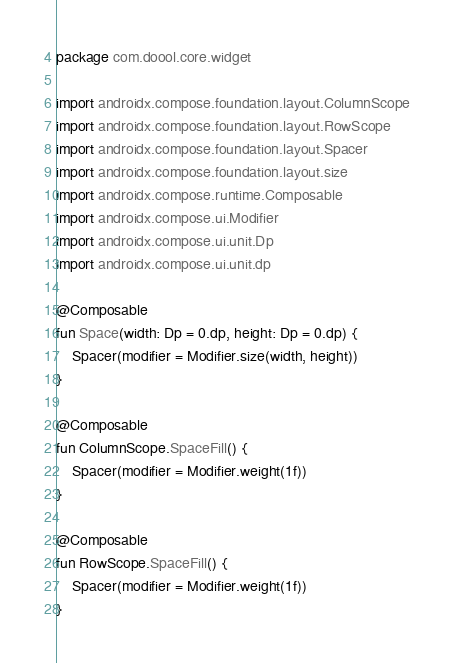Convert code to text. <code><loc_0><loc_0><loc_500><loc_500><_Kotlin_>package com.doool.core.widget

import androidx.compose.foundation.layout.ColumnScope
import androidx.compose.foundation.layout.RowScope
import androidx.compose.foundation.layout.Spacer
import androidx.compose.foundation.layout.size
import androidx.compose.runtime.Composable
import androidx.compose.ui.Modifier
import androidx.compose.ui.unit.Dp
import androidx.compose.ui.unit.dp

@Composable
fun Space(width: Dp = 0.dp, height: Dp = 0.dp) {
    Spacer(modifier = Modifier.size(width, height))
}

@Composable
fun ColumnScope.SpaceFill() {
    Spacer(modifier = Modifier.weight(1f))
}

@Composable
fun RowScope.SpaceFill() {
    Spacer(modifier = Modifier.weight(1f))
}
</code> 